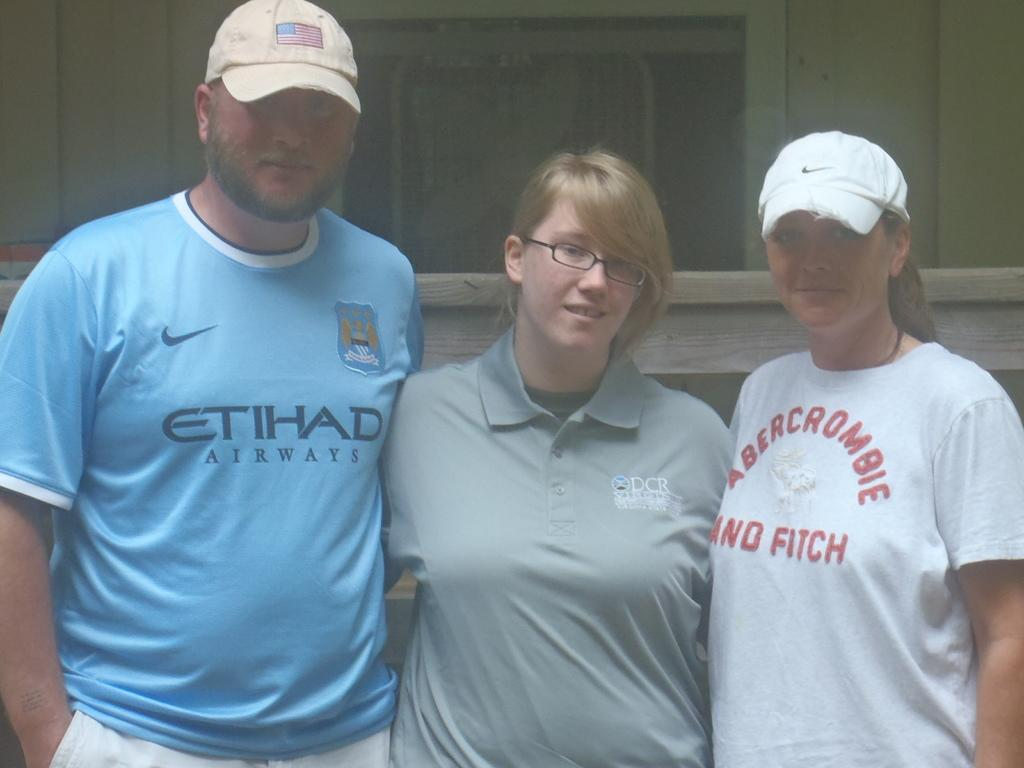<image>
Relay a brief, clear account of the picture shown. three people are standing together and one has an abercrombie and fitch shirt on 